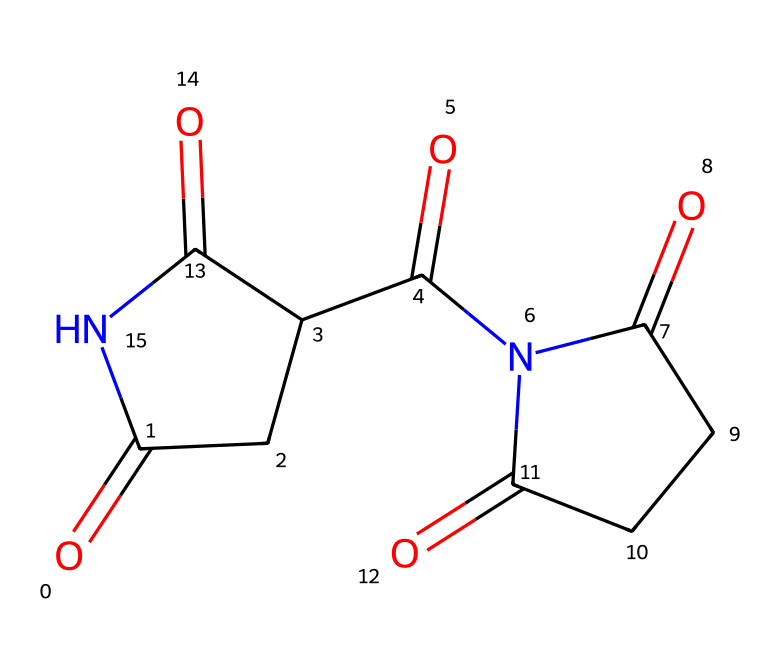What is the molecular formula of thalidomide? To determine the molecular formula from the SMILES representation, we count the atoms. The structure shows 13 carbons, 11 hydrogens, 4 oxygens, and 2 nitrogens. Therefore, the molecular formula is C13H10N2O4.
Answer: C13H10N2O4 How many rings are present in the thalidomide structure? By analyzing the structure, we see two distinct cyclic groups in the imide structure. Each cycle is formed by carbon atoms and contributes to the overall architecture of the compound. Thus, there are 2 rings in total.
Answer: 2 What functional groups are present in thalidomide? Observing the structure, it is evident that there are imide functional groups (formed by the carbonyls and nitrogen atoms) and ketone groups (attached directly to the carbon). These are significant features, which are characteristic of thalidomide.
Answer: imide and ketone How many nitrogen atoms are in thalidomide? The SMILES representation reveals 2 instances of nitrogen within the structure. Since nitrogen is a part of the imide functional group, we can count them directly from the structure. Therefore, we find 2 nitrogen atoms.
Answer: 2 Is thalidomide an example of an imide? The structure clearly shows the characteristic carbonyl-N-carbonyl sequence which is unique to imides. Given this specific pairing of carbon and nitrogen with carbonyl groups, it classifies thalidomide as an imide.
Answer: yes What is the primary use of thalidomide? Generally, thalidomide is known for its historical use as a sedative and later as a treatment for certain conditions like leprosy. Analyzing its properties, we can summarize its application in the medical field.
Answer: treatment for leprosy 